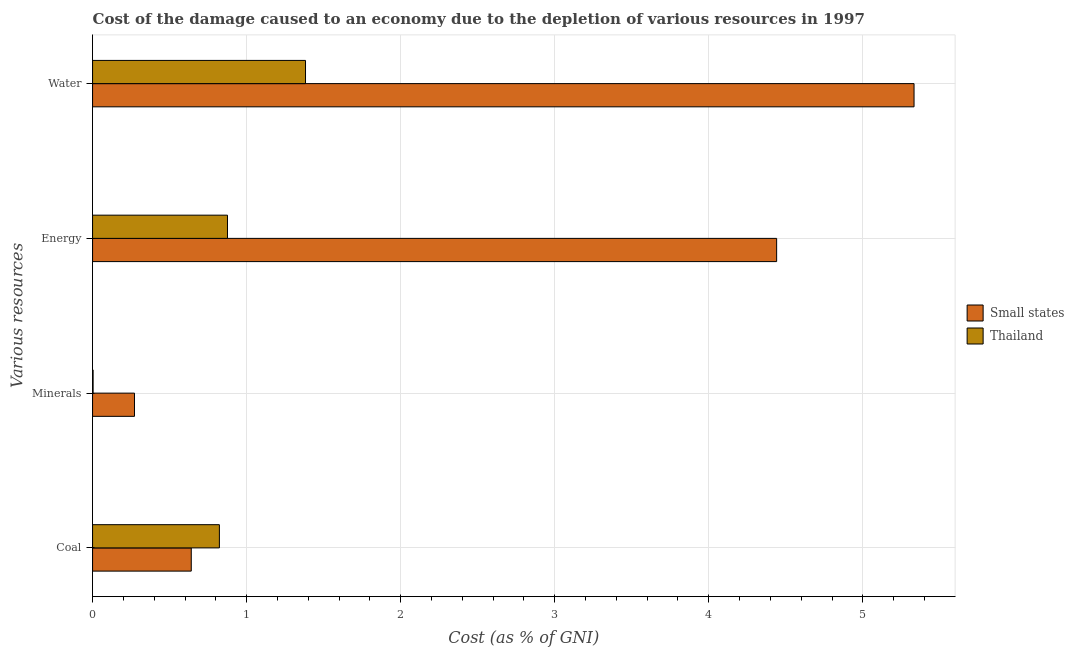Are the number of bars per tick equal to the number of legend labels?
Keep it short and to the point. Yes. Are the number of bars on each tick of the Y-axis equal?
Keep it short and to the point. Yes. What is the label of the 1st group of bars from the top?
Ensure brevity in your answer.  Water. What is the cost of damage due to depletion of energy in Small states?
Your response must be concise. 4.44. Across all countries, what is the maximum cost of damage due to depletion of energy?
Keep it short and to the point. 4.44. Across all countries, what is the minimum cost of damage due to depletion of coal?
Provide a succinct answer. 0.64. In which country was the cost of damage due to depletion of minerals maximum?
Your answer should be compact. Small states. In which country was the cost of damage due to depletion of energy minimum?
Your response must be concise. Thailand. What is the total cost of damage due to depletion of energy in the graph?
Keep it short and to the point. 5.32. What is the difference between the cost of damage due to depletion of energy in Thailand and that in Small states?
Provide a succinct answer. -3.56. What is the difference between the cost of damage due to depletion of minerals in Thailand and the cost of damage due to depletion of energy in Small states?
Make the answer very short. -4.44. What is the average cost of damage due to depletion of energy per country?
Your answer should be compact. 2.66. What is the difference between the cost of damage due to depletion of energy and cost of damage due to depletion of water in Thailand?
Your answer should be very brief. -0.51. In how many countries, is the cost of damage due to depletion of water greater than 2.2 %?
Provide a short and direct response. 1. What is the ratio of the cost of damage due to depletion of minerals in Thailand to that in Small states?
Give a very brief answer. 0.01. What is the difference between the highest and the second highest cost of damage due to depletion of energy?
Ensure brevity in your answer.  3.56. What is the difference between the highest and the lowest cost of damage due to depletion of energy?
Offer a terse response. 3.56. Is it the case that in every country, the sum of the cost of damage due to depletion of water and cost of damage due to depletion of coal is greater than the sum of cost of damage due to depletion of energy and cost of damage due to depletion of minerals?
Make the answer very short. Yes. What does the 2nd bar from the top in Coal represents?
Give a very brief answer. Small states. What does the 1st bar from the bottom in Coal represents?
Make the answer very short. Small states. How many bars are there?
Offer a terse response. 8. Are all the bars in the graph horizontal?
Offer a very short reply. Yes. How many countries are there in the graph?
Your answer should be compact. 2. Are the values on the major ticks of X-axis written in scientific E-notation?
Give a very brief answer. No. What is the title of the graph?
Make the answer very short. Cost of the damage caused to an economy due to the depletion of various resources in 1997 . Does "Estonia" appear as one of the legend labels in the graph?
Make the answer very short. No. What is the label or title of the X-axis?
Make the answer very short. Cost (as % of GNI). What is the label or title of the Y-axis?
Keep it short and to the point. Various resources. What is the Cost (as % of GNI) in Small states in Coal?
Offer a terse response. 0.64. What is the Cost (as % of GNI) of Thailand in Coal?
Offer a terse response. 0.82. What is the Cost (as % of GNI) in Small states in Minerals?
Provide a succinct answer. 0.27. What is the Cost (as % of GNI) of Thailand in Minerals?
Offer a very short reply. 0. What is the Cost (as % of GNI) in Small states in Energy?
Provide a short and direct response. 4.44. What is the Cost (as % of GNI) of Thailand in Energy?
Keep it short and to the point. 0.88. What is the Cost (as % of GNI) of Small states in Water?
Offer a very short reply. 5.33. What is the Cost (as % of GNI) in Thailand in Water?
Give a very brief answer. 1.38. Across all Various resources, what is the maximum Cost (as % of GNI) in Small states?
Your answer should be compact. 5.33. Across all Various resources, what is the maximum Cost (as % of GNI) of Thailand?
Give a very brief answer. 1.38. Across all Various resources, what is the minimum Cost (as % of GNI) of Small states?
Keep it short and to the point. 0.27. Across all Various resources, what is the minimum Cost (as % of GNI) of Thailand?
Give a very brief answer. 0. What is the total Cost (as % of GNI) in Small states in the graph?
Offer a terse response. 10.69. What is the total Cost (as % of GNI) in Thailand in the graph?
Give a very brief answer. 3.08. What is the difference between the Cost (as % of GNI) in Small states in Coal and that in Minerals?
Ensure brevity in your answer.  0.37. What is the difference between the Cost (as % of GNI) of Thailand in Coal and that in Minerals?
Ensure brevity in your answer.  0.82. What is the difference between the Cost (as % of GNI) in Small states in Coal and that in Energy?
Keep it short and to the point. -3.8. What is the difference between the Cost (as % of GNI) in Thailand in Coal and that in Energy?
Provide a succinct answer. -0.05. What is the difference between the Cost (as % of GNI) in Small states in Coal and that in Water?
Make the answer very short. -4.69. What is the difference between the Cost (as % of GNI) in Thailand in Coal and that in Water?
Ensure brevity in your answer.  -0.56. What is the difference between the Cost (as % of GNI) of Small states in Minerals and that in Energy?
Your answer should be very brief. -4.17. What is the difference between the Cost (as % of GNI) of Thailand in Minerals and that in Energy?
Your answer should be compact. -0.87. What is the difference between the Cost (as % of GNI) in Small states in Minerals and that in Water?
Provide a succinct answer. -5.06. What is the difference between the Cost (as % of GNI) in Thailand in Minerals and that in Water?
Offer a terse response. -1.38. What is the difference between the Cost (as % of GNI) in Small states in Energy and that in Water?
Offer a terse response. -0.89. What is the difference between the Cost (as % of GNI) in Thailand in Energy and that in Water?
Give a very brief answer. -0.51. What is the difference between the Cost (as % of GNI) in Small states in Coal and the Cost (as % of GNI) in Thailand in Minerals?
Your answer should be compact. 0.64. What is the difference between the Cost (as % of GNI) of Small states in Coal and the Cost (as % of GNI) of Thailand in Energy?
Offer a very short reply. -0.24. What is the difference between the Cost (as % of GNI) in Small states in Coal and the Cost (as % of GNI) in Thailand in Water?
Offer a very short reply. -0.74. What is the difference between the Cost (as % of GNI) of Small states in Minerals and the Cost (as % of GNI) of Thailand in Energy?
Provide a succinct answer. -0.6. What is the difference between the Cost (as % of GNI) of Small states in Minerals and the Cost (as % of GNI) of Thailand in Water?
Your response must be concise. -1.11. What is the difference between the Cost (as % of GNI) of Small states in Energy and the Cost (as % of GNI) of Thailand in Water?
Offer a very short reply. 3.06. What is the average Cost (as % of GNI) of Small states per Various resources?
Your response must be concise. 2.67. What is the average Cost (as % of GNI) of Thailand per Various resources?
Offer a terse response. 0.77. What is the difference between the Cost (as % of GNI) in Small states and Cost (as % of GNI) in Thailand in Coal?
Give a very brief answer. -0.18. What is the difference between the Cost (as % of GNI) in Small states and Cost (as % of GNI) in Thailand in Minerals?
Your answer should be very brief. 0.27. What is the difference between the Cost (as % of GNI) in Small states and Cost (as % of GNI) in Thailand in Energy?
Ensure brevity in your answer.  3.56. What is the difference between the Cost (as % of GNI) in Small states and Cost (as % of GNI) in Thailand in Water?
Your response must be concise. 3.95. What is the ratio of the Cost (as % of GNI) of Small states in Coal to that in Minerals?
Your answer should be very brief. 2.35. What is the ratio of the Cost (as % of GNI) in Thailand in Coal to that in Minerals?
Offer a terse response. 234.72. What is the ratio of the Cost (as % of GNI) of Small states in Coal to that in Energy?
Offer a very short reply. 0.14. What is the ratio of the Cost (as % of GNI) of Thailand in Coal to that in Energy?
Provide a short and direct response. 0.94. What is the ratio of the Cost (as % of GNI) of Small states in Coal to that in Water?
Your response must be concise. 0.12. What is the ratio of the Cost (as % of GNI) in Thailand in Coal to that in Water?
Offer a very short reply. 0.6. What is the ratio of the Cost (as % of GNI) in Small states in Minerals to that in Energy?
Your response must be concise. 0.06. What is the ratio of the Cost (as % of GNI) of Thailand in Minerals to that in Energy?
Provide a succinct answer. 0. What is the ratio of the Cost (as % of GNI) of Small states in Minerals to that in Water?
Your answer should be compact. 0.05. What is the ratio of the Cost (as % of GNI) of Thailand in Minerals to that in Water?
Give a very brief answer. 0. What is the ratio of the Cost (as % of GNI) of Small states in Energy to that in Water?
Make the answer very short. 0.83. What is the ratio of the Cost (as % of GNI) in Thailand in Energy to that in Water?
Provide a short and direct response. 0.63. What is the difference between the highest and the second highest Cost (as % of GNI) of Small states?
Your response must be concise. 0.89. What is the difference between the highest and the second highest Cost (as % of GNI) of Thailand?
Your answer should be very brief. 0.51. What is the difference between the highest and the lowest Cost (as % of GNI) in Small states?
Keep it short and to the point. 5.06. What is the difference between the highest and the lowest Cost (as % of GNI) of Thailand?
Keep it short and to the point. 1.38. 